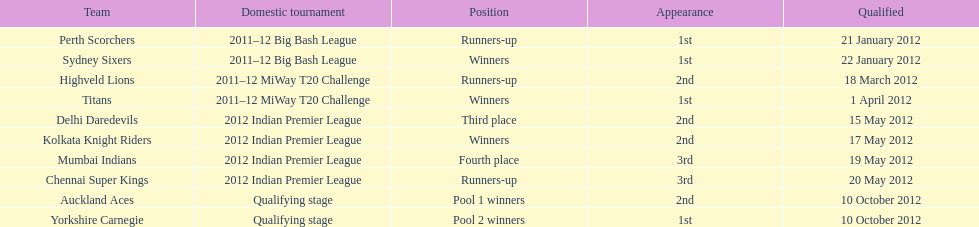In the 2012 indian premier league, which team emerged as the winner? Kolkata Knight Riders. 